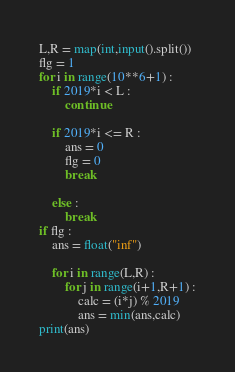Convert code to text. <code><loc_0><loc_0><loc_500><loc_500><_Python_>L,R = map(int,input().split())
flg = 1
for i in range(10**6+1) :
    if 2019*i < L :
        continue
    
    if 2019*i <= R :
        ans = 0
        flg = 0
        break
    
    else :
        break
if flg :
    ans = float("inf")
    
    for i in range(L,R) :
        for j in range(i+1,R+1) :
            calc = (i*j) % 2019
            ans = min(ans,calc)
print(ans)
</code> 